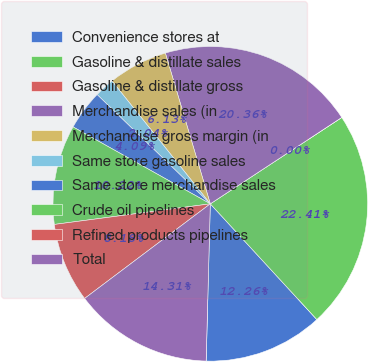<chart> <loc_0><loc_0><loc_500><loc_500><pie_chart><fcel>Convenience stores at<fcel>Gasoline & distillate sales<fcel>Gasoline & distillate gross<fcel>Merchandise sales (in<fcel>Merchandise gross margin (in<fcel>Same store gasoline sales<fcel>Same store merchandise sales<fcel>Crude oil pipelines<fcel>Refined products pipelines<fcel>Total<nl><fcel>12.26%<fcel>22.41%<fcel>0.0%<fcel>20.36%<fcel>6.13%<fcel>2.04%<fcel>4.09%<fcel>10.22%<fcel>8.18%<fcel>14.31%<nl></chart> 